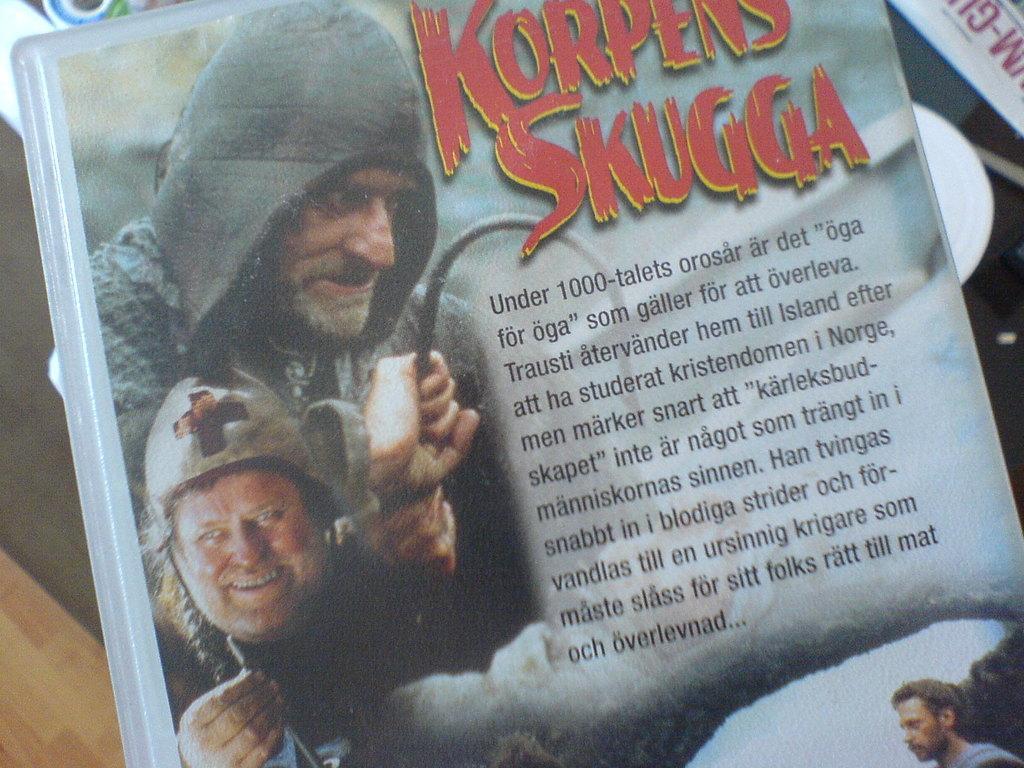In one or two sentences, can you explain what this image depicts? In this image we can see a book. In the background there is a floor. 